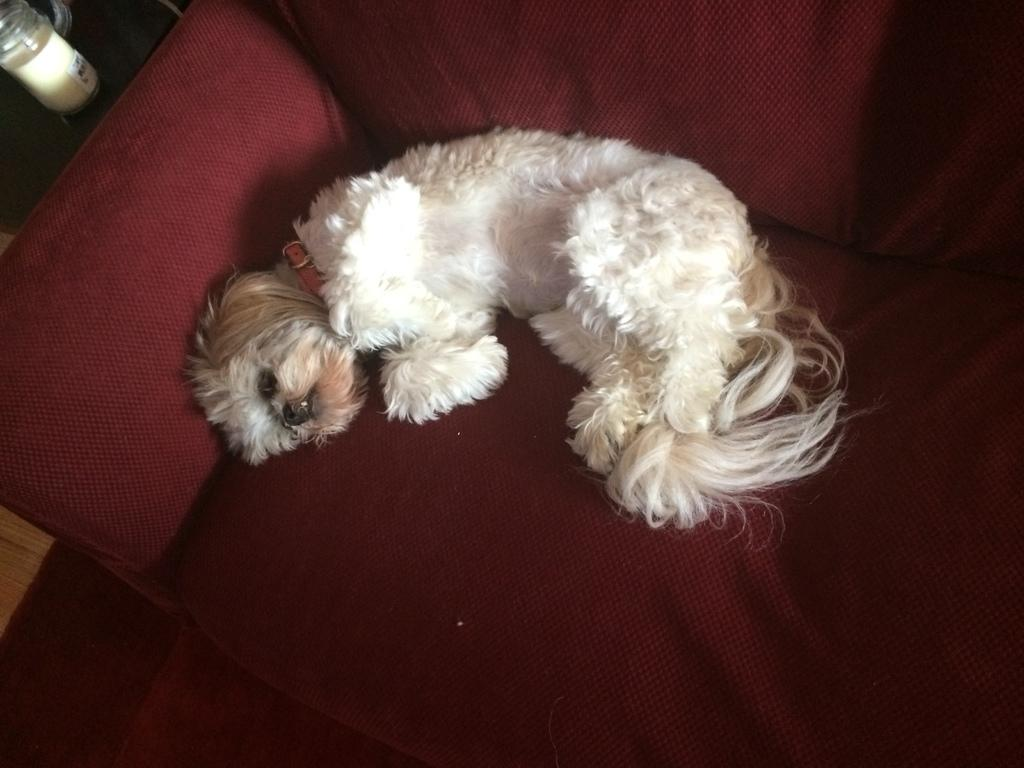What type of animal is in the image? There is a dog in the image. Where is the dog located? The dog is lying on a sofa. What other piece of furniture is visible in the image? There is a table in the image. What object is on the table? There is a jar on the table. What type of seed is growing on the dog's fur in the image? There is no seed growing on the dog's fur in the image; it is not mentioned in the facts provided. 